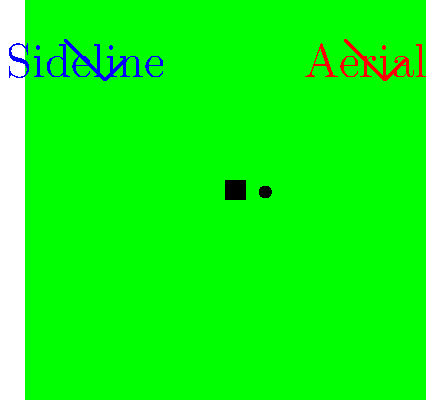Analyze the impact of sideline versus aerial camera angles on viewer perception during a football game. Which camera angle would likely provide a more accurate representation of player positions and ball movement for technical analysis? To answer this question, we need to consider the following factors:

1. Perspective: 
   - Sideline cameras offer a horizontal view of the field, which can distort depth perception.
   - Aerial cameras provide a top-down view, offering a more accurate representation of spatial relationships.

2. Field coverage:
   - Sideline cameras have limited field coverage, often focusing on specific areas or players.
   - Aerial cameras can capture a wider area of the field, showing more players and their relative positions.

3. Ball trajectory:
   - Sideline cameras may struggle to accurately depict the height and arc of passes or kicks.
   - Aerial cameras can more clearly show the ball's path and landing spot.

4. Player movement:
   - Sideline cameras excel at showing lateral movement and speed.
   - Aerial cameras better represent player positioning and formation structures.

5. Technical analysis:
   - For analyzing plays, formations, and tactical decisions, a bird's-eye view is generally more informative.
   - Aerial angles allow for better assessment of spacing between players and overall field utilization.

6. Technological considerations:
   - Modern broadcast technology often uses a combination of camera angles, including computer-generated views.
   - Software can now create 3D reconstructions of plays using data from multiple camera angles.

Given these factors, the aerial camera angle would likely provide a more accurate representation of player positions and ball movement for technical analysis. It offers a clearer view of spatial relationships on the field, which is crucial for understanding play development and tactical decisions.
Answer: Aerial camera angle 